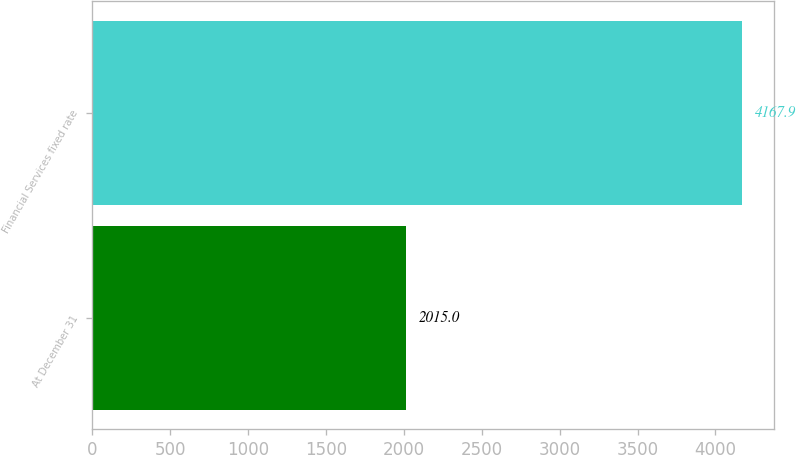Convert chart to OTSL. <chart><loc_0><loc_0><loc_500><loc_500><bar_chart><fcel>At December 31<fcel>Financial Services fixed rate<nl><fcel>2015<fcel>4167.9<nl></chart> 